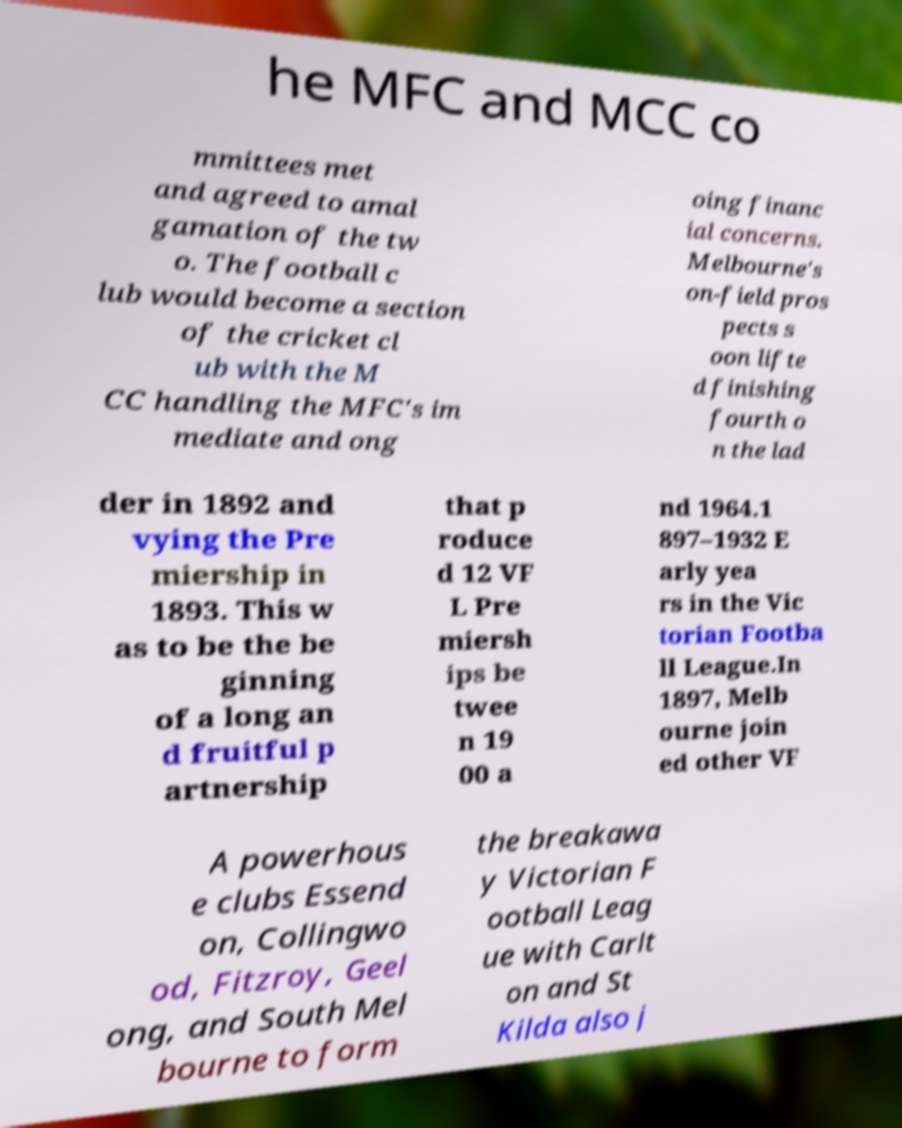For documentation purposes, I need the text within this image transcribed. Could you provide that? he MFC and MCC co mmittees met and agreed to amal gamation of the tw o. The football c lub would become a section of the cricket cl ub with the M CC handling the MFC's im mediate and ong oing financ ial concerns. Melbourne's on-field pros pects s oon lifte d finishing fourth o n the lad der in 1892 and vying the Pre miership in 1893. This w as to be the be ginning of a long an d fruitful p artnership that p roduce d 12 VF L Pre miersh ips be twee n 19 00 a nd 1964.1 897–1932 E arly yea rs in the Vic torian Footba ll League.In 1897, Melb ourne join ed other VF A powerhous e clubs Essend on, Collingwo od, Fitzroy, Geel ong, and South Mel bourne to form the breakawa y Victorian F ootball Leag ue with Carlt on and St Kilda also j 